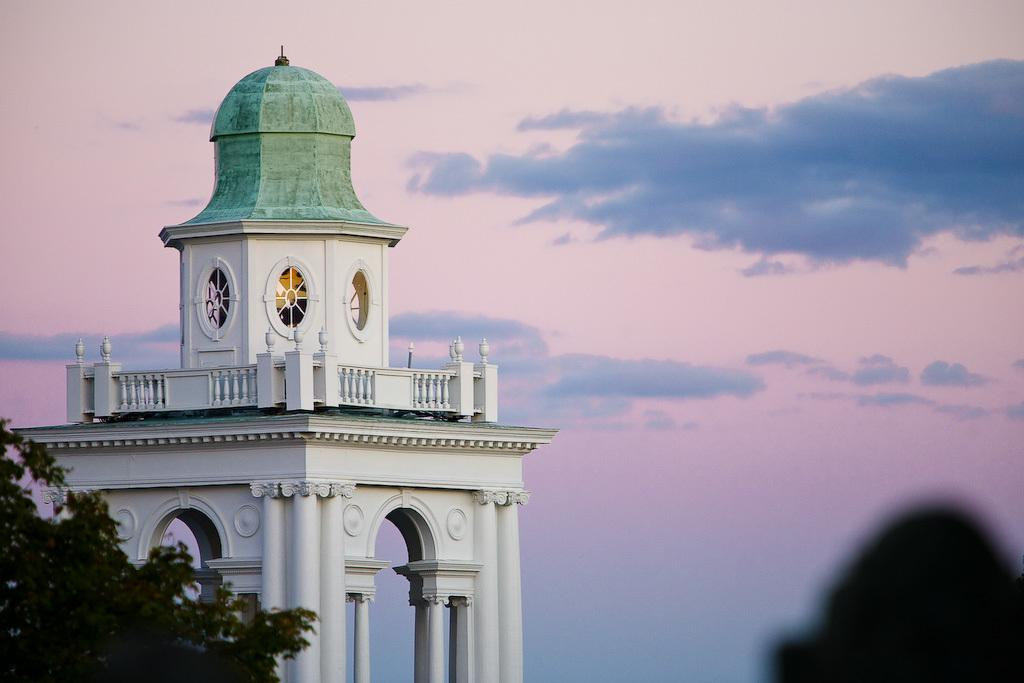What type of structure is located on the left side of the image? There is a white color building on the left side of the image. What other object is on the left side of the image? There is a tree on the left side of the image. What can be seen at the bottom right corner of the image? There is some shadow on the right bottom of the image. What is visible in the background of the image? The sky is visible in the image. What type of veil is covering the tree in the image? There is no veil present in the image; the tree is not covered. How does the brush affect the appearance of the building in the image? There is no brush present in the image, so it does not affect the appearance of the building. 